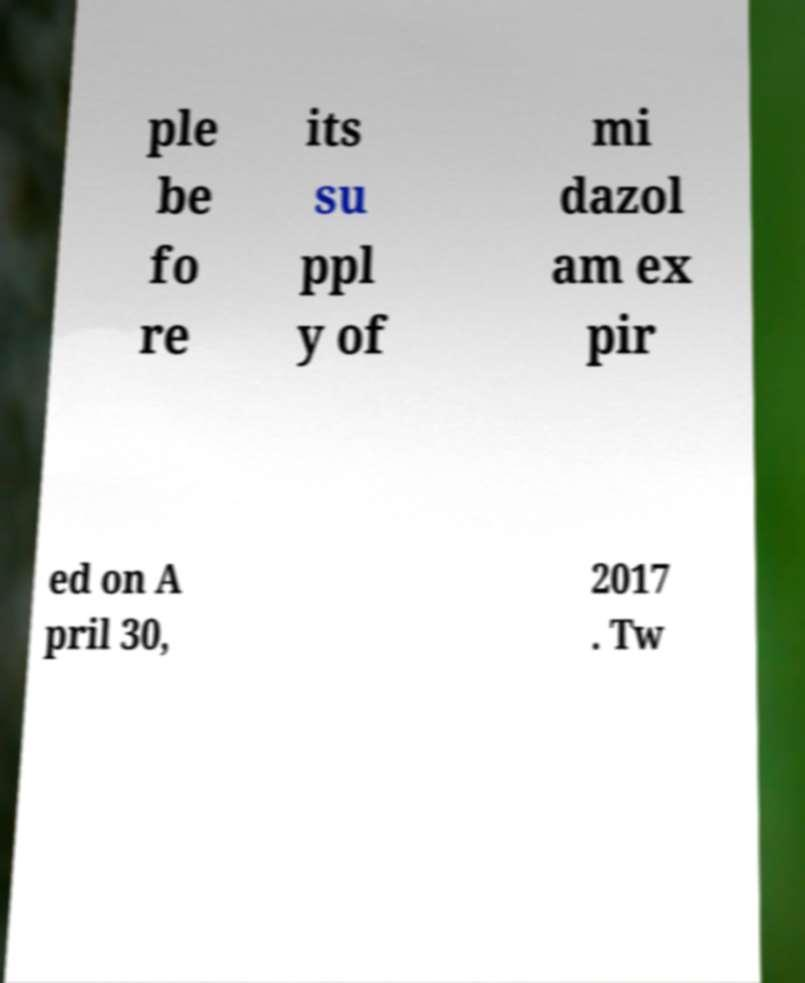For documentation purposes, I need the text within this image transcribed. Could you provide that? ple be fo re its su ppl y of mi dazol am ex pir ed on A pril 30, 2017 . Tw 